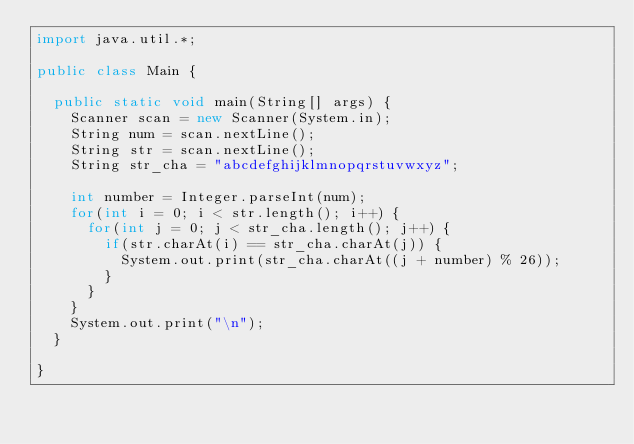Convert code to text. <code><loc_0><loc_0><loc_500><loc_500><_Java_>import java.util.*;

public class Main {

	public static void main(String[] args) {
		Scanner scan = new Scanner(System.in);
		String num = scan.nextLine();
		String str = scan.nextLine();
		String str_cha = "abcdefghijklmnopqrstuvwxyz";

		int number = Integer.parseInt(num);
		for(int i = 0; i < str.length(); i++) {
			for(int j = 0; j < str_cha.length(); j++) {
				if(str.charAt(i) == str_cha.charAt(j)) {
					System.out.print(str_cha.charAt((j + number) % 26));
				}
			}
		}
		System.out.print("\n");
	}

}
</code> 